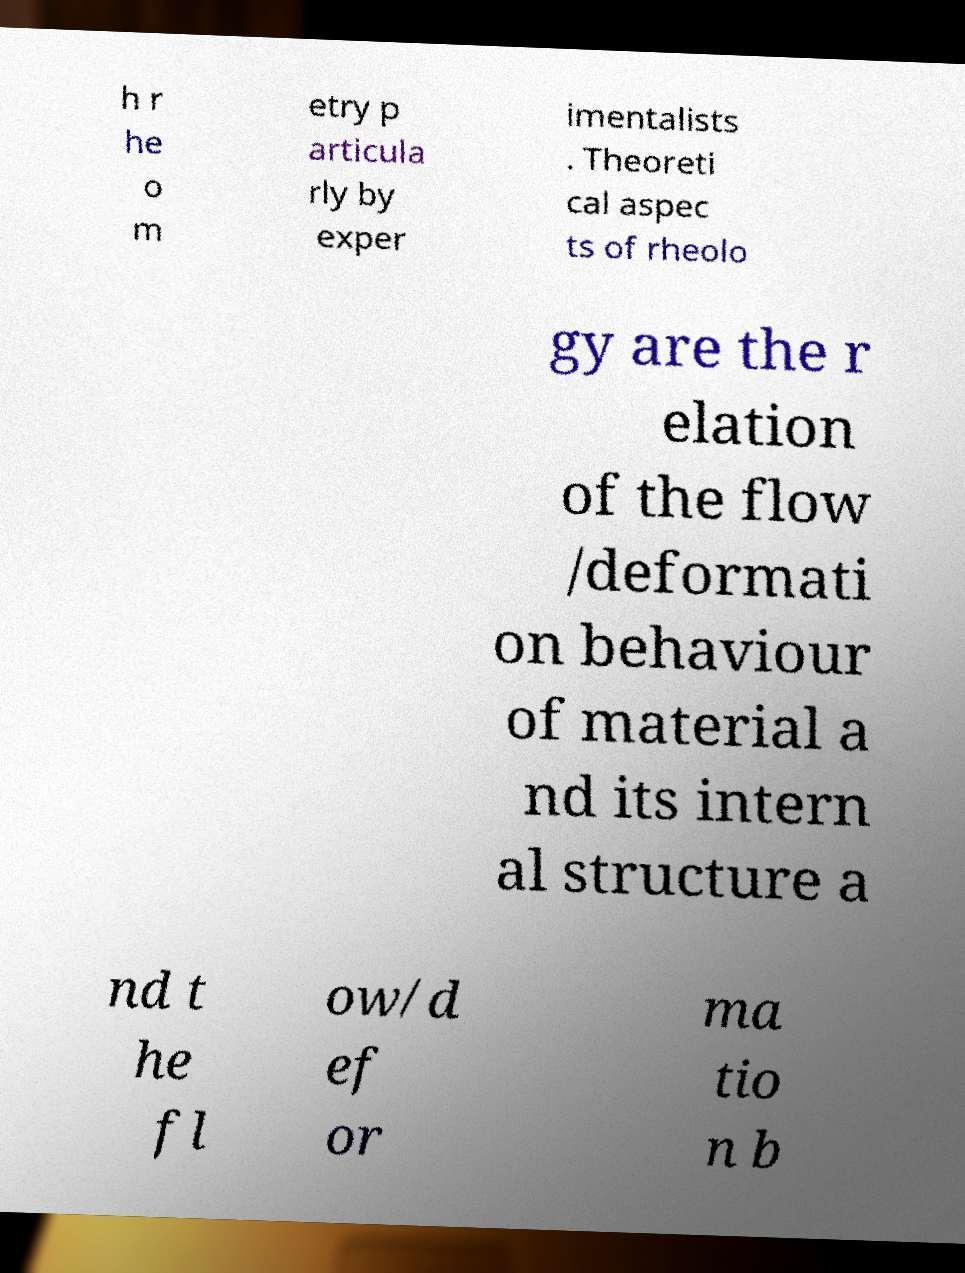For documentation purposes, I need the text within this image transcribed. Could you provide that? h r he o m etry p articula rly by exper imentalists . Theoreti cal aspec ts of rheolo gy are the r elation of the flow /deformati on behaviour of material a nd its intern al structure a nd t he fl ow/d ef or ma tio n b 